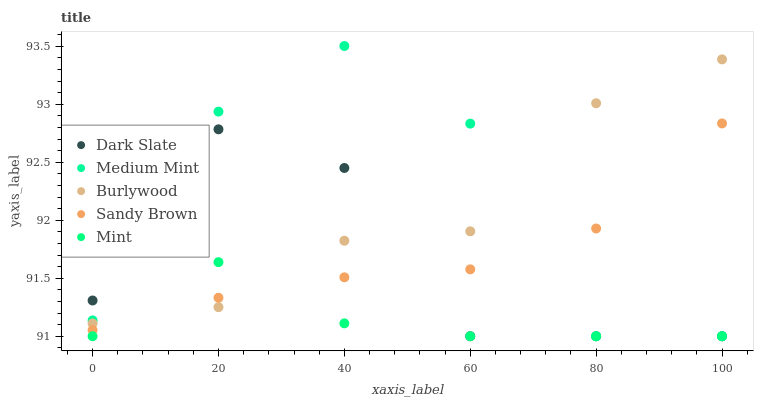Does Mint have the minimum area under the curve?
Answer yes or no. Yes. Does Medium Mint have the maximum area under the curve?
Answer yes or no. Yes. Does Dark Slate have the minimum area under the curve?
Answer yes or no. No. Does Dark Slate have the maximum area under the curve?
Answer yes or no. No. Is Sandy Brown the smoothest?
Answer yes or no. Yes. Is Medium Mint the roughest?
Answer yes or no. Yes. Is Dark Slate the smoothest?
Answer yes or no. No. Is Dark Slate the roughest?
Answer yes or no. No. Does Medium Mint have the lowest value?
Answer yes or no. Yes. Does Sandy Brown have the lowest value?
Answer yes or no. No. Does Medium Mint have the highest value?
Answer yes or no. Yes. Does Dark Slate have the highest value?
Answer yes or no. No. Does Medium Mint intersect Sandy Brown?
Answer yes or no. Yes. Is Medium Mint less than Sandy Brown?
Answer yes or no. No. Is Medium Mint greater than Sandy Brown?
Answer yes or no. No. 